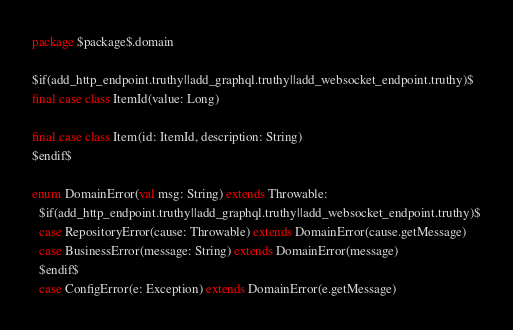Convert code to text. <code><loc_0><loc_0><loc_500><loc_500><_Scala_>package $package$.domain

$if(add_http_endpoint.truthy||add_graphql.truthy||add_websocket_endpoint.truthy)$
final case class ItemId(value: Long)

final case class Item(id: ItemId, description: String)
$endif$

enum DomainError(val msg: String) extends Throwable:
  $if(add_http_endpoint.truthy||add_graphql.truthy||add_websocket_endpoint.truthy)$
  case RepositoryError(cause: Throwable) extends DomainError(cause.getMessage)
  case BusinessError(message: String) extends DomainError(message)
  $endif$
  case ConfigError(e: Exception) extends DomainError(e.getMessage)
</code> 